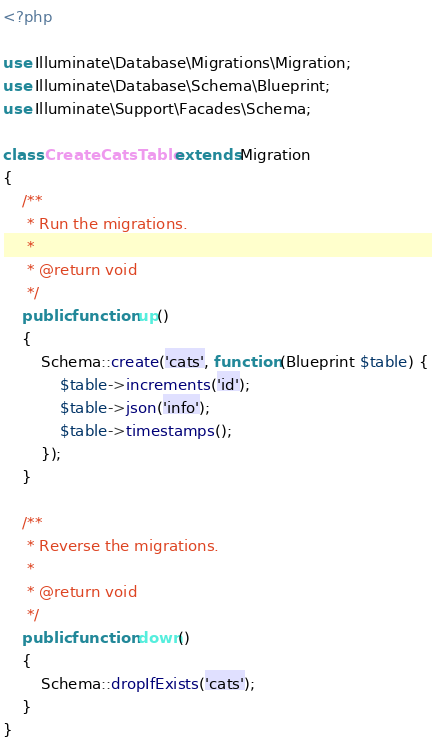Convert code to text. <code><loc_0><loc_0><loc_500><loc_500><_PHP_><?php

use Illuminate\Database\Migrations\Migration;
use Illuminate\Database\Schema\Blueprint;
use Illuminate\Support\Facades\Schema;

class CreateCatsTable extends Migration
{
    /**
     * Run the migrations.
     *
     * @return void
     */
    public function up()
    {
        Schema::create('cats', function (Blueprint $table) {
            $table->increments('id');
            $table->json('info');
            $table->timestamps();
        });
    }

    /**
     * Reverse the migrations.
     *
     * @return void
     */
    public function down()
    {
        Schema::dropIfExists('cats');
    }
}
</code> 